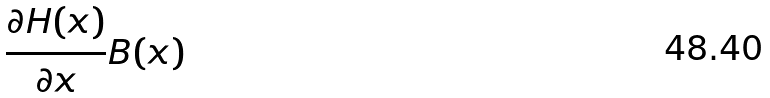Convert formula to latex. <formula><loc_0><loc_0><loc_500><loc_500>\frac { \partial H ( x ) } { \partial x } B ( x )</formula> 